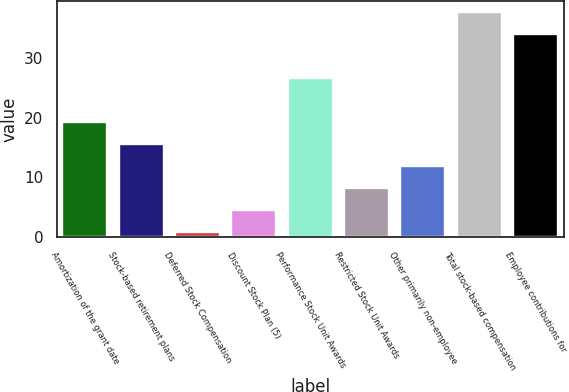<chart> <loc_0><loc_0><loc_500><loc_500><bar_chart><fcel>Amortization of the grant date<fcel>Stock-based retirement plans<fcel>Deferred Stock Compensation<fcel>Discount Stock Plan (5)<fcel>Performance Stock Unit Awards<fcel>Restricted Stock Unit Awards<fcel>Other primarily non-employee<fcel>Total stock-based compensation<fcel>Employee contributions for<nl><fcel>19.25<fcel>15.58<fcel>0.9<fcel>4.57<fcel>26.59<fcel>8.24<fcel>11.91<fcel>37.6<fcel>33.93<nl></chart> 